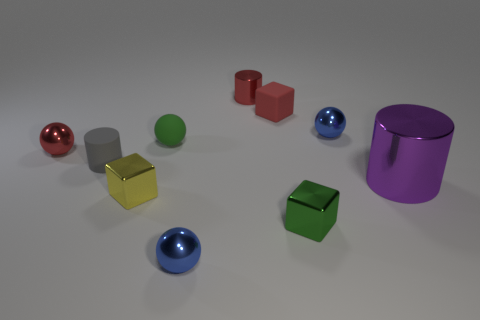Subtract 1 spheres. How many spheres are left? 3 Subtract all gray blocks. How many blue balls are left? 2 Subtract all purple spheres. Subtract all red blocks. How many spheres are left? 4 Subtract all cylinders. How many objects are left? 7 Add 6 big cylinders. How many big cylinders are left? 7 Add 4 red matte things. How many red matte things exist? 5 Subtract 0 brown balls. How many objects are left? 10 Subtract all yellow things. Subtract all purple objects. How many objects are left? 8 